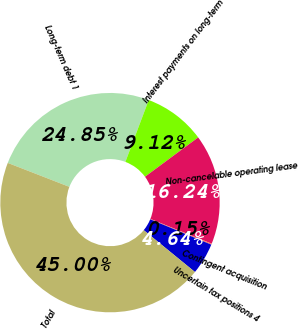Convert chart. <chart><loc_0><loc_0><loc_500><loc_500><pie_chart><fcel>Long-term debt 1<fcel>Interest payments on long-term<fcel>Non-cancelable operating lease<fcel>Contingent acquisition<fcel>Uncertain tax positions 4<fcel>Total<nl><fcel>24.85%<fcel>9.12%<fcel>16.24%<fcel>0.15%<fcel>4.64%<fcel>45.0%<nl></chart> 